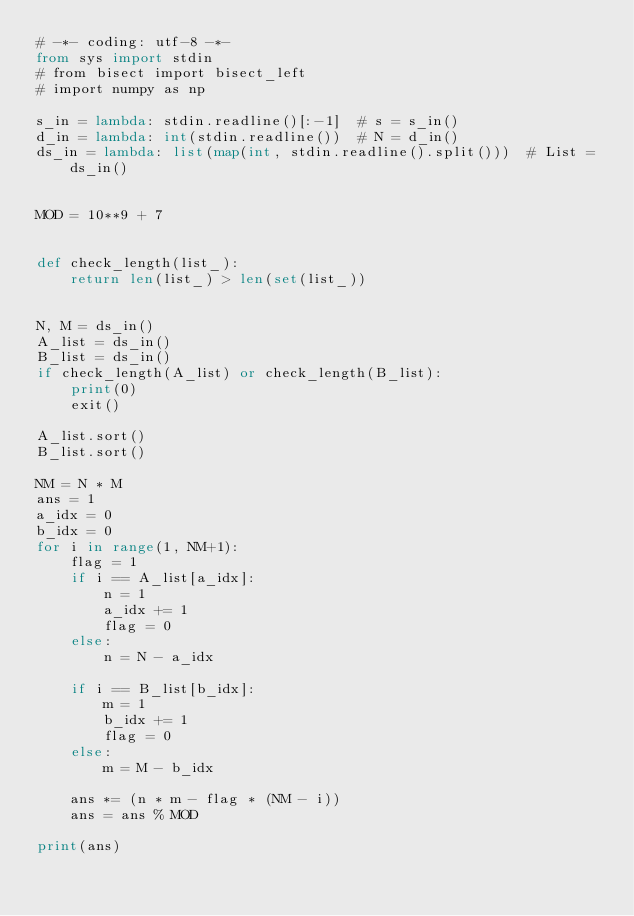Convert code to text. <code><loc_0><loc_0><loc_500><loc_500><_Python_># -*- coding: utf-8 -*-
from sys import stdin
# from bisect import bisect_left
# import numpy as np

s_in = lambda: stdin.readline()[:-1]  # s = s_in()
d_in = lambda: int(stdin.readline())  # N = d_in()
ds_in = lambda: list(map(int, stdin.readline().split()))  # List = ds_in()


MOD = 10**9 + 7


def check_length(list_):
    return len(list_) > len(set(list_))


N, M = ds_in()
A_list = ds_in()
B_list = ds_in()
if check_length(A_list) or check_length(B_list):
    print(0)
    exit()

A_list.sort()
B_list.sort()

NM = N * M
ans = 1
a_idx = 0
b_idx = 0
for i in range(1, NM+1):
    flag = 1
    if i == A_list[a_idx]:
        n = 1
        a_idx += 1
        flag = 0
    else:
        n = N - a_idx

    if i == B_list[b_idx]:
        m = 1
        b_idx += 1
        flag = 0
    else:
        m = M - b_idx

    ans *= (n * m - flag * (NM - i))
    ans = ans % MOD

print(ans)
</code> 